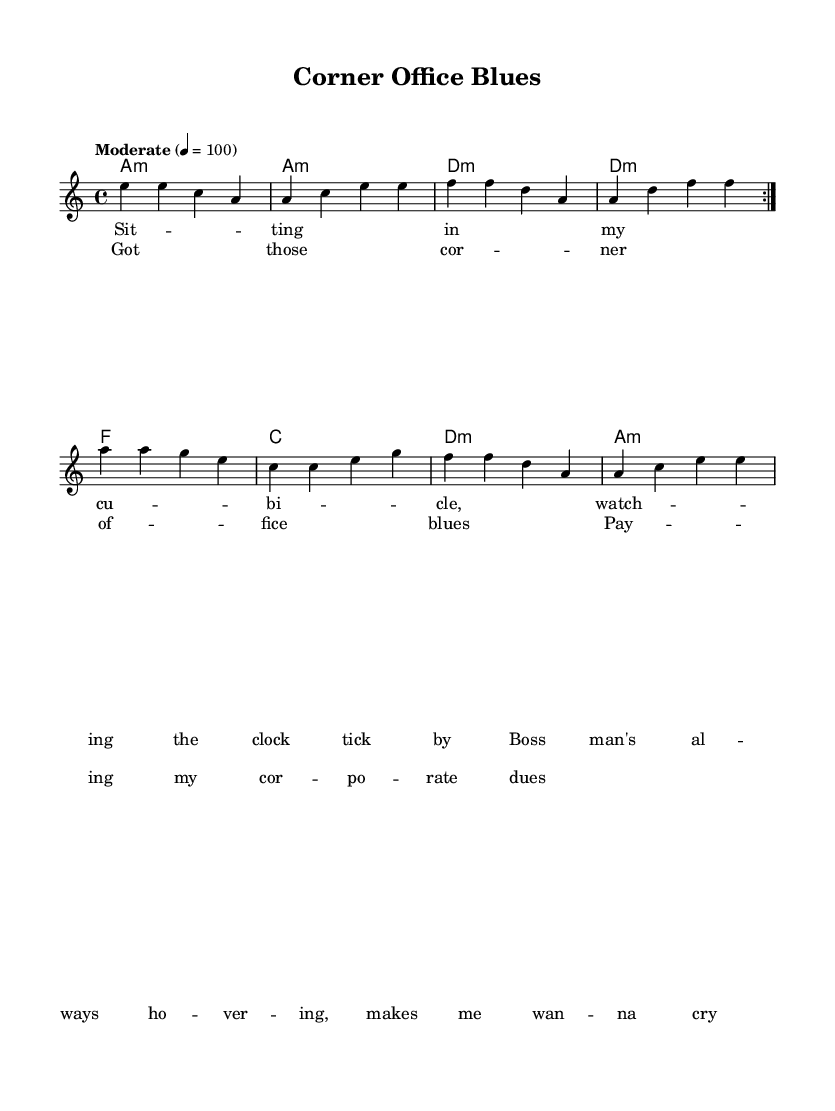What is the key signature of this music? The key signature is indicated at the beginning of the score. It shows an A minor key, which typically has no sharps or flats. Thus, it's in the relative minor of C major.
Answer: A minor What is the time signature? The time signature is shown right after the key signature in the beginning. It indicates that there are four beats in each measure and the quarter note gets the beat.
Answer: 4/4 What is the tempo marking? The tempo marking specifies the speed of the piece, which is written as "Moderate" followed by a metronome mark of 100 beats per minute. This indicates a moderate pace for the performance.
Answer: Moderate 4 = 100 How many measures does the verse section have? The verse section consists of two repeated sections, each with four measures. Counting the measures gives a total of eight measures.
Answer: 8 What chords are used in the harmonies? The chords in the harmonies are A minor, D minor, F major, and C major. These chords are indicated in the chord names below the staff and represent the harmonic structure of the piece.
Answer: A minor, D minor, F major, C major What type of blues does this piece represent? This piece represents modern blues rock, which often incorporates elements of traditional blues and rock music with a focus on contemporary themes, such as workplace dynamics and leadership.
Answer: Modern blues rock 